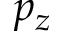<formula> <loc_0><loc_0><loc_500><loc_500>p _ { z }</formula> 